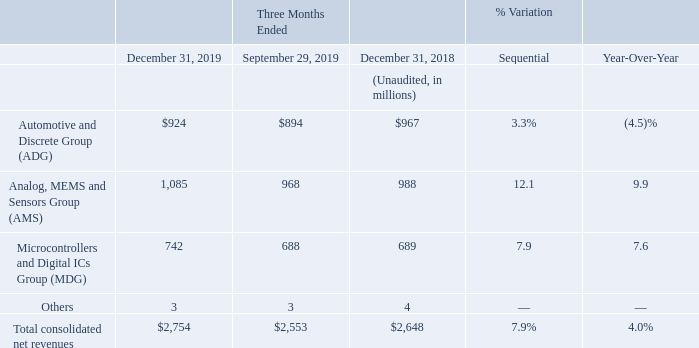On a sequential basis, ADG revenues were up 3.3%, driven by an increase in volumes of approximately 8%, partially offset by a decrease in average selling prices of approximately 5%, mostly attributable to product mix.
AMS revenues increased 12.1% driven by Analog and Imaging products. AMS increase was due to an increase of approximately 5% in average selling prices, entirely due to product mix, and to higher volumes of approximately of 7%.
MDG revenues increased by 7.9%, mainly driven by Microcontrollers, due to both higher average selling prices of approximately 6%, entirely due to product mix, and higher volumes of approximately 2%.
On a year-over-year basis, fourth quarter net revenues increased by 4.0%. ADG revenues decreased 4.5% compared to the year-ago quarter on lower revenues in both Automotive and Power Discrete. The decrease was entirely due to lower average selling prices of approximately 4%, while volumes remained substantially flat. The decrease in average selling prices was a combination of less favorable product mix and lower selling prices.
AMS fourth quarter revenues grew 9.9% year-over-year, mainly driven by Analog and Imaging. The increase was entirely due to higher average selling prices of approximately 18%, entirely attributable to product mix,
partially offset by lower volumes of approximately 8%. MDG fourth quarter revenues increased by 7.6%, mainly driven by Microcontrollers. The increase was due to higher average selling prices of approximately 9%,
entirely due to improved product mix.
What led to increase in the revenue of ADG on sequential basis? Driven by an increase in volumes of approximately 8%, partially offset by a decrease in average selling prices of approximately 5%, mostly attributable to product mix. What led to increase in the revenue of AMS on sequential basis? Driven by analog and imaging products. ams increase was due to an increase of approximately 5% in average selling prices, entirely due to product mix, and to higher volumes of approximately of 7%. What led to increase in the revenue of MDG on sequential basis? Driven by microcontrollers, due to both higher average selling prices of approximately 6%, entirely due to product mix, and higher volumes of approximately 2%. What is the average net revenues from Automotive and Discrete Group (ADG) for the period December 31, 2019 and 2018?
Answer scale should be: million. (924+967) / 2
Answer: 945.5. What is the average net revenues from Analog, MEMS and Sensors Group (AMS) for the period December 31, 2019 and 2018?
Answer scale should be: million. (1,085+988) / 2
Answer: 1036.5. What is the average net revenues from Microcontrollers and Digital ICs Group (MDG) for the period December 31, 2019 and 2018?
Answer scale should be: million. (742+689) / 2 
Answer: 715.5. 